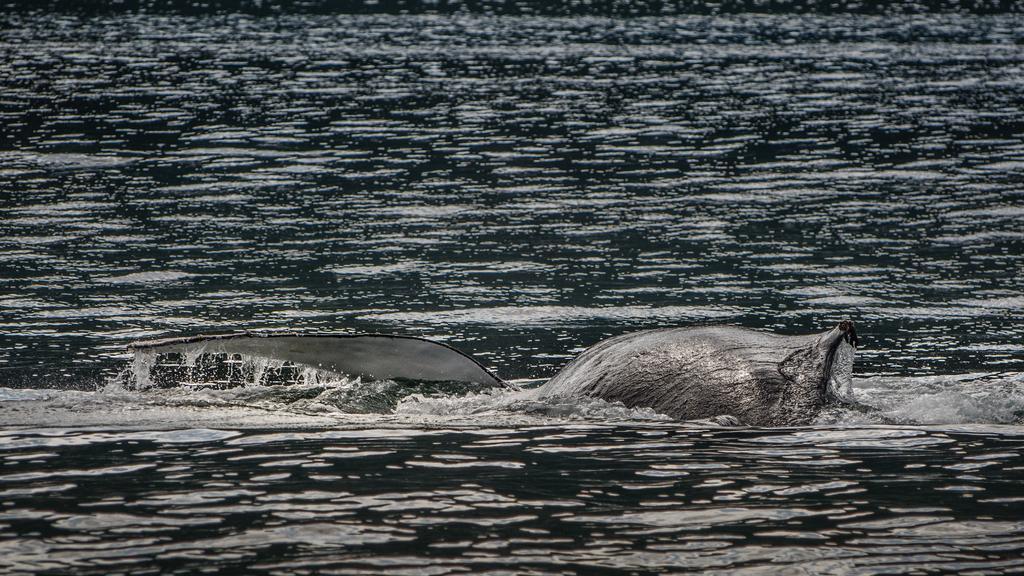Could you give a brief overview of what you see in this image? In this image we can see an aquatic animal in the water body. 